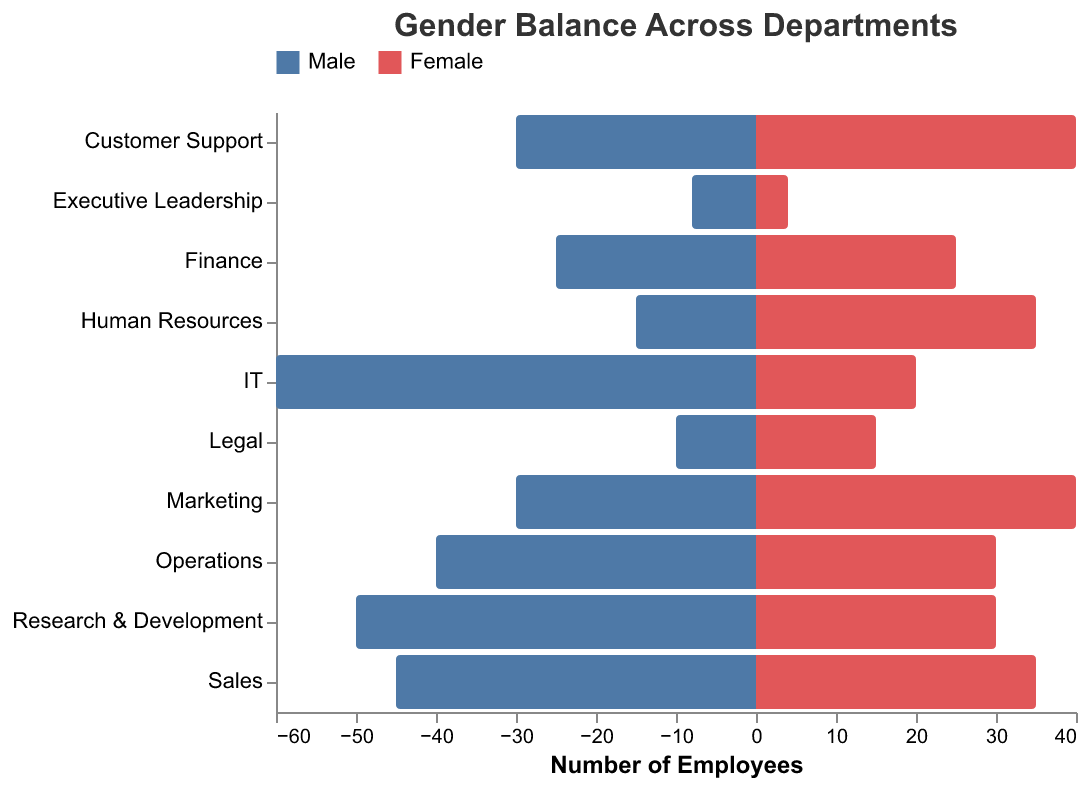What is the title of the figure? The title is prominently displayed at the top of the figure. It reads "Gender Balance Across Departments".
Answer: Gender Balance Across Departments What colors are used to represent males and females in the figure? The key at the top of the figure shows two colors, blueish for males and reddish for females.
Answer: Blue for males, Red for females Which department has the highest number of female employees? By examining the figure, the department with the longest bar to the right (representing females) is "Human Resources," with a value of 35.
Answer: Human Resources Which department has the least gender balance, and how is this determined? The least gender balance is in the IT department. This is determined by the large disparity between the male (60) and female (20) populations in this department.
Answer: IT What is the total number of employees in Research & Development? The figure shows 50 males and 30 females in R&D. Summing these values gives the total number of employees.
Answer: 80 Which department has an equal number of male and female employees? By observing the bars' lengths for both males and females, the Finance department has equal lengths, each showing 25.
Answer: Finance How does the number of males in the Executive Leadership department compare to the number of males in the Legal department? The number of males in Executive Leadership (8) is less than that in the Legal department (10), as shown by the shorter bar length.
Answer: Lower What is the gender ratio difference in Customer Support? Customer Support has 30 males and 40 females. Subtracting the smaller value from the larger gives the gender ratio difference: 40 - 30.
Answer: 10 Which department has the second-highest number of male employees? By comparing the bars for male employees, Sales has the second-highest value of 45, after IT which has 60.
Answer: Sales Does the Operations department have more males or females, and by how much? Operations has 40 males and 30 females. The difference is calculated as 40 - 30.
Answer: 10 more males 